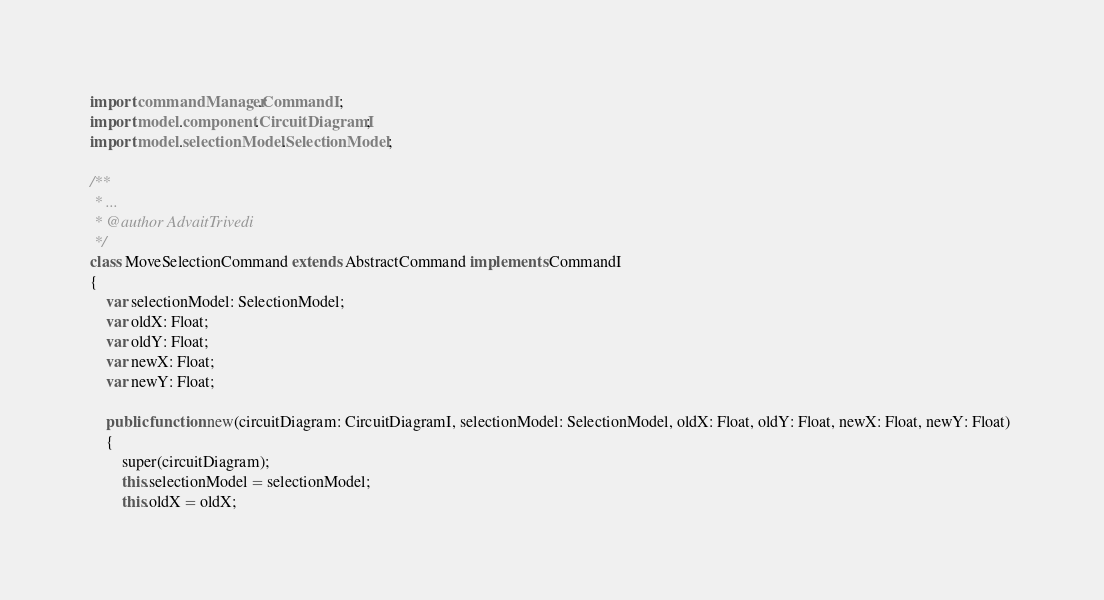<code> <loc_0><loc_0><loc_500><loc_500><_Haxe_>
import commandManager.CommandI ;
import model.component.CircuitDiagramI;
import model.selectionModel.SelectionModel;

/**
 * ...
 * @author AdvaitTrivedi
 */
class MoveSelectionCommand extends AbstractCommand implements CommandI
{
	var selectionModel: SelectionModel;
	var oldX: Float;
	var oldY: Float;
	var newX: Float;
	var newY: Float;
	
	public function new(circuitDiagram: CircuitDiagramI, selectionModel: SelectionModel, oldX: Float, oldY: Float, newX: Float, newY: Float) 
	{
		super(circuitDiagram);
		this.selectionModel = selectionModel;
		this.oldX = oldX;</code> 